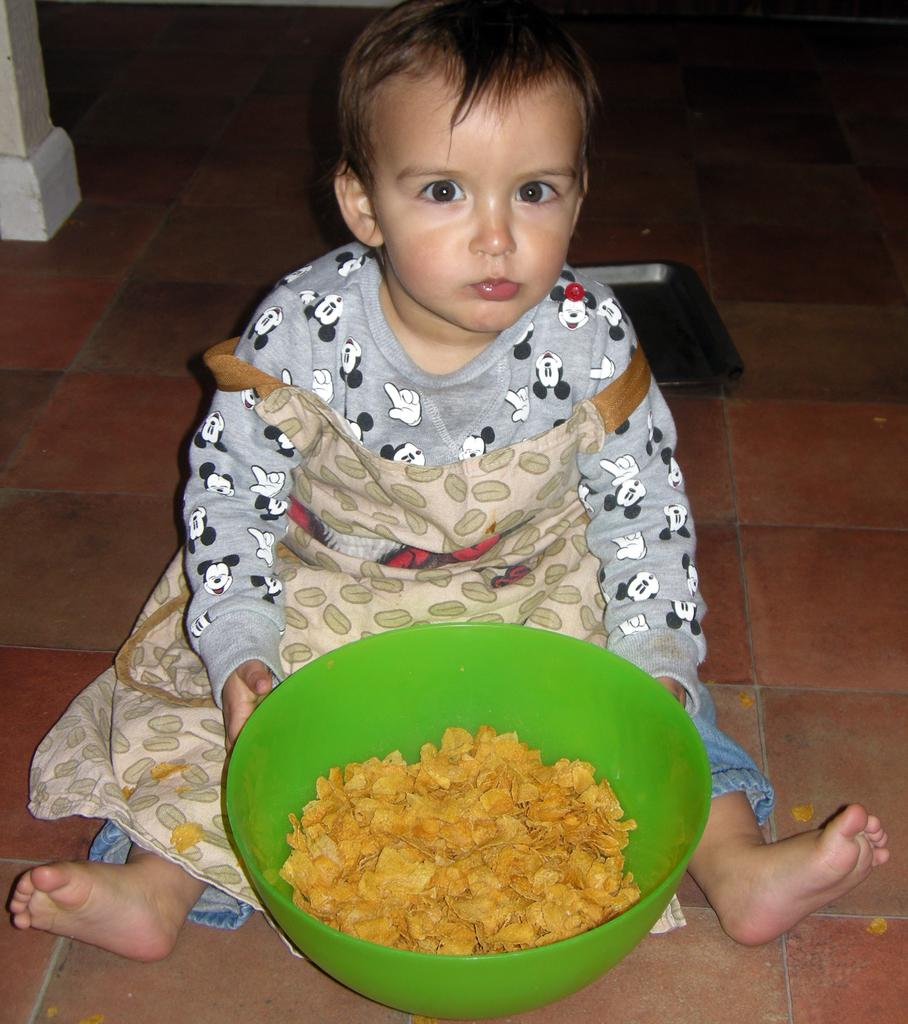What is the main subject of the image? There is a kid sitting in the center of the image. What is the kid holding in the image? The kid is holding a bowl. What can be found inside the bowl? There is a food item in the bowl. Can you describe any other objects visible in the background of the image? There are other objects visible in the background of the image. What type of tub can be seen in the background of the image? There is no tub present in the background of the image. 